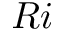Convert formula to latex. <formula><loc_0><loc_0><loc_500><loc_500>R i</formula> 